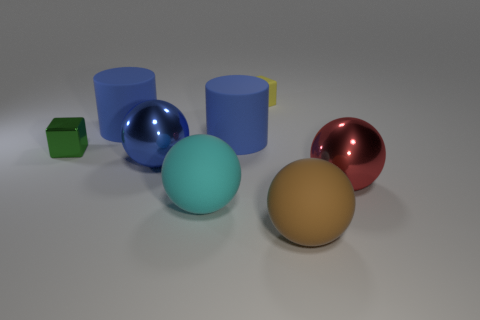Add 1 big blue rubber cylinders. How many objects exist? 9 Subtract all cylinders. How many objects are left? 6 Subtract all large blue cylinders. Subtract all yellow matte things. How many objects are left? 5 Add 7 big blue shiny objects. How many big blue shiny objects are left? 8 Add 8 large purple rubber blocks. How many large purple rubber blocks exist? 8 Subtract 1 brown spheres. How many objects are left? 7 